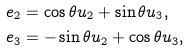<formula> <loc_0><loc_0><loc_500><loc_500>& e _ { 2 } = \cos \theta u _ { 2 } + \sin \theta u _ { 3 } , \\ & e _ { 3 } = - \sin \theta u _ { 2 } + \cos \theta u _ { 3 } ,</formula> 